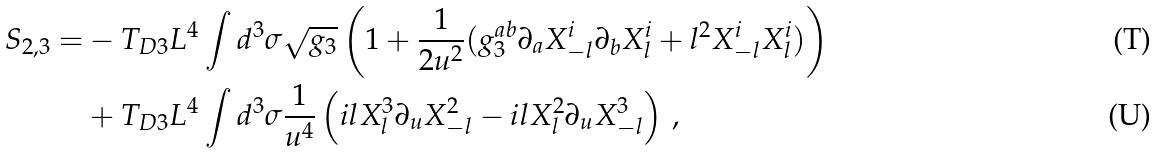<formula> <loc_0><loc_0><loc_500><loc_500>S _ { 2 , 3 } = & - T _ { D 3 } L ^ { 4 } \int d ^ { 3 } \sigma \sqrt { g _ { 3 } } \left ( 1 + \frac { 1 } { 2 u ^ { 2 } } ( g _ { 3 } ^ { a b } \partial _ { a } X _ { - l } ^ { i } \partial _ { b } X ^ { i } _ { l } + l ^ { 2 } X ^ { i } _ { - l } X ^ { i } _ { l } ) \right ) \\ & + T _ { D 3 } L ^ { 4 } \int d ^ { 3 } \sigma \frac { 1 } { u ^ { 4 } } \left ( i l X _ { l } ^ { 3 } \partial _ { u } X _ { - l } ^ { 2 } - i l X ^ { 2 } _ { l } \partial _ { u } X _ { - l } ^ { 3 } \right ) \, ,</formula> 